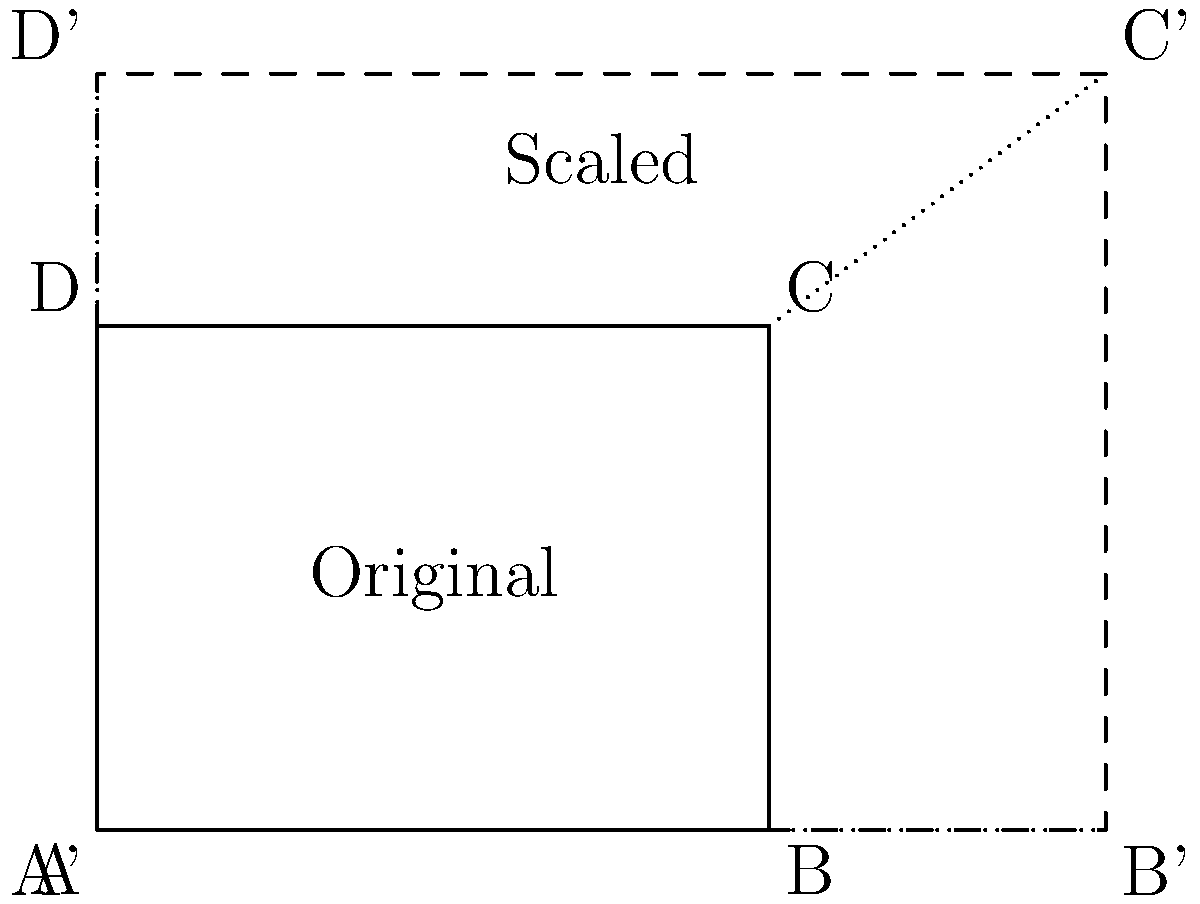You have a rectangular tourist itinerary map with dimensions 4 units by 3 units, designed for a 5-day trip. A client wants to extend the trip to 7.5 days while keeping the same route. If you need to scale the map proportionally to fit the new trip duration, what will be the dimensions of the new scaled map? To solve this problem, we need to follow these steps:

1. Determine the scale factor:
   - Original trip duration: 5 days
   - New trip duration: 7.5 days
   - Scale factor = New duration / Original duration
   - Scale factor = 7.5 / 5 = 1.5

2. Apply the scale factor to the original dimensions:
   - Original width: 4 units
   - Original height: 3 units
   - New width = Original width × Scale factor = 4 × 1.5 = 6 units
   - New height = Original height × Scale factor = 3 × 1.5 = 4.5 units

Therefore, the new dimensions of the scaled map will be 6 units by 4.5 units.

This scaling preserves the aspect ratio of the original map while expanding it to accommodate the longer trip duration. The new map will be 1.5 times larger in both dimensions, allowing for the same route to be represented over a longer time period.
Answer: 6 units by 4.5 units 